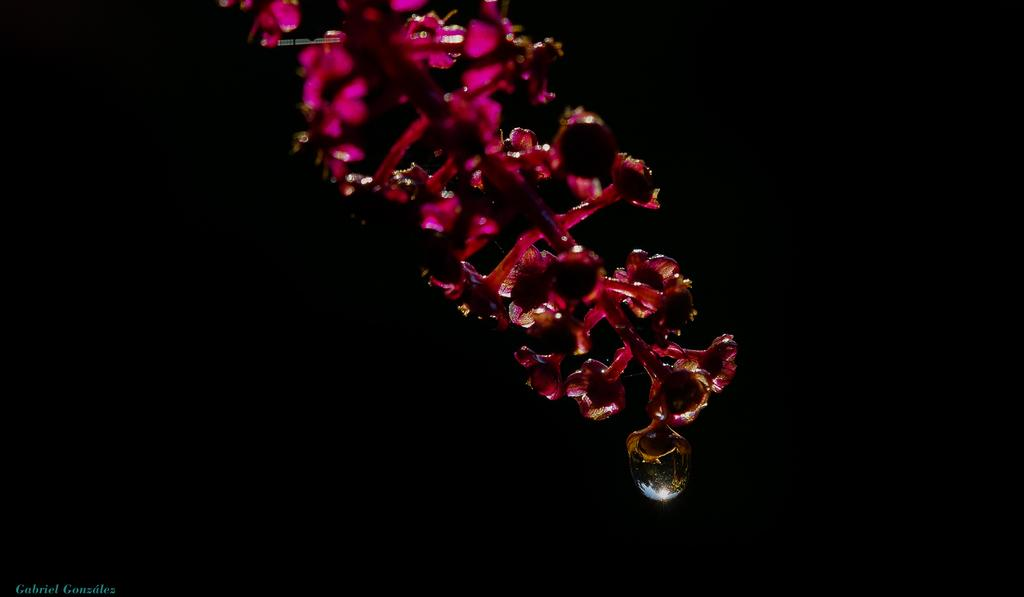What is present in the image? There is a plant in the image. What can be observed about the background of the image? The background of the image is dark. What type of reaction does the queen have to the fictional story in the image? There is no queen or fictional story present in the image; it only features a plant with a dark background. 